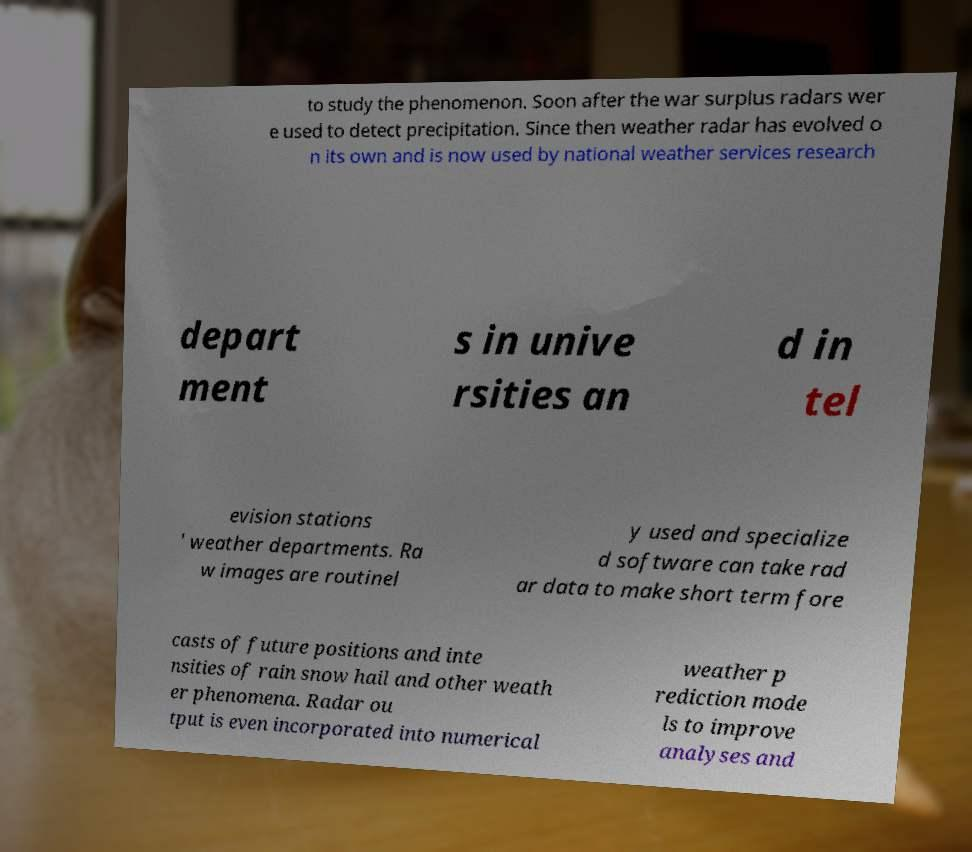There's text embedded in this image that I need extracted. Can you transcribe it verbatim? to study the phenomenon. Soon after the war surplus radars wer e used to detect precipitation. Since then weather radar has evolved o n its own and is now used by national weather services research depart ment s in unive rsities an d in tel evision stations ' weather departments. Ra w images are routinel y used and specialize d software can take rad ar data to make short term fore casts of future positions and inte nsities of rain snow hail and other weath er phenomena. Radar ou tput is even incorporated into numerical weather p rediction mode ls to improve analyses and 